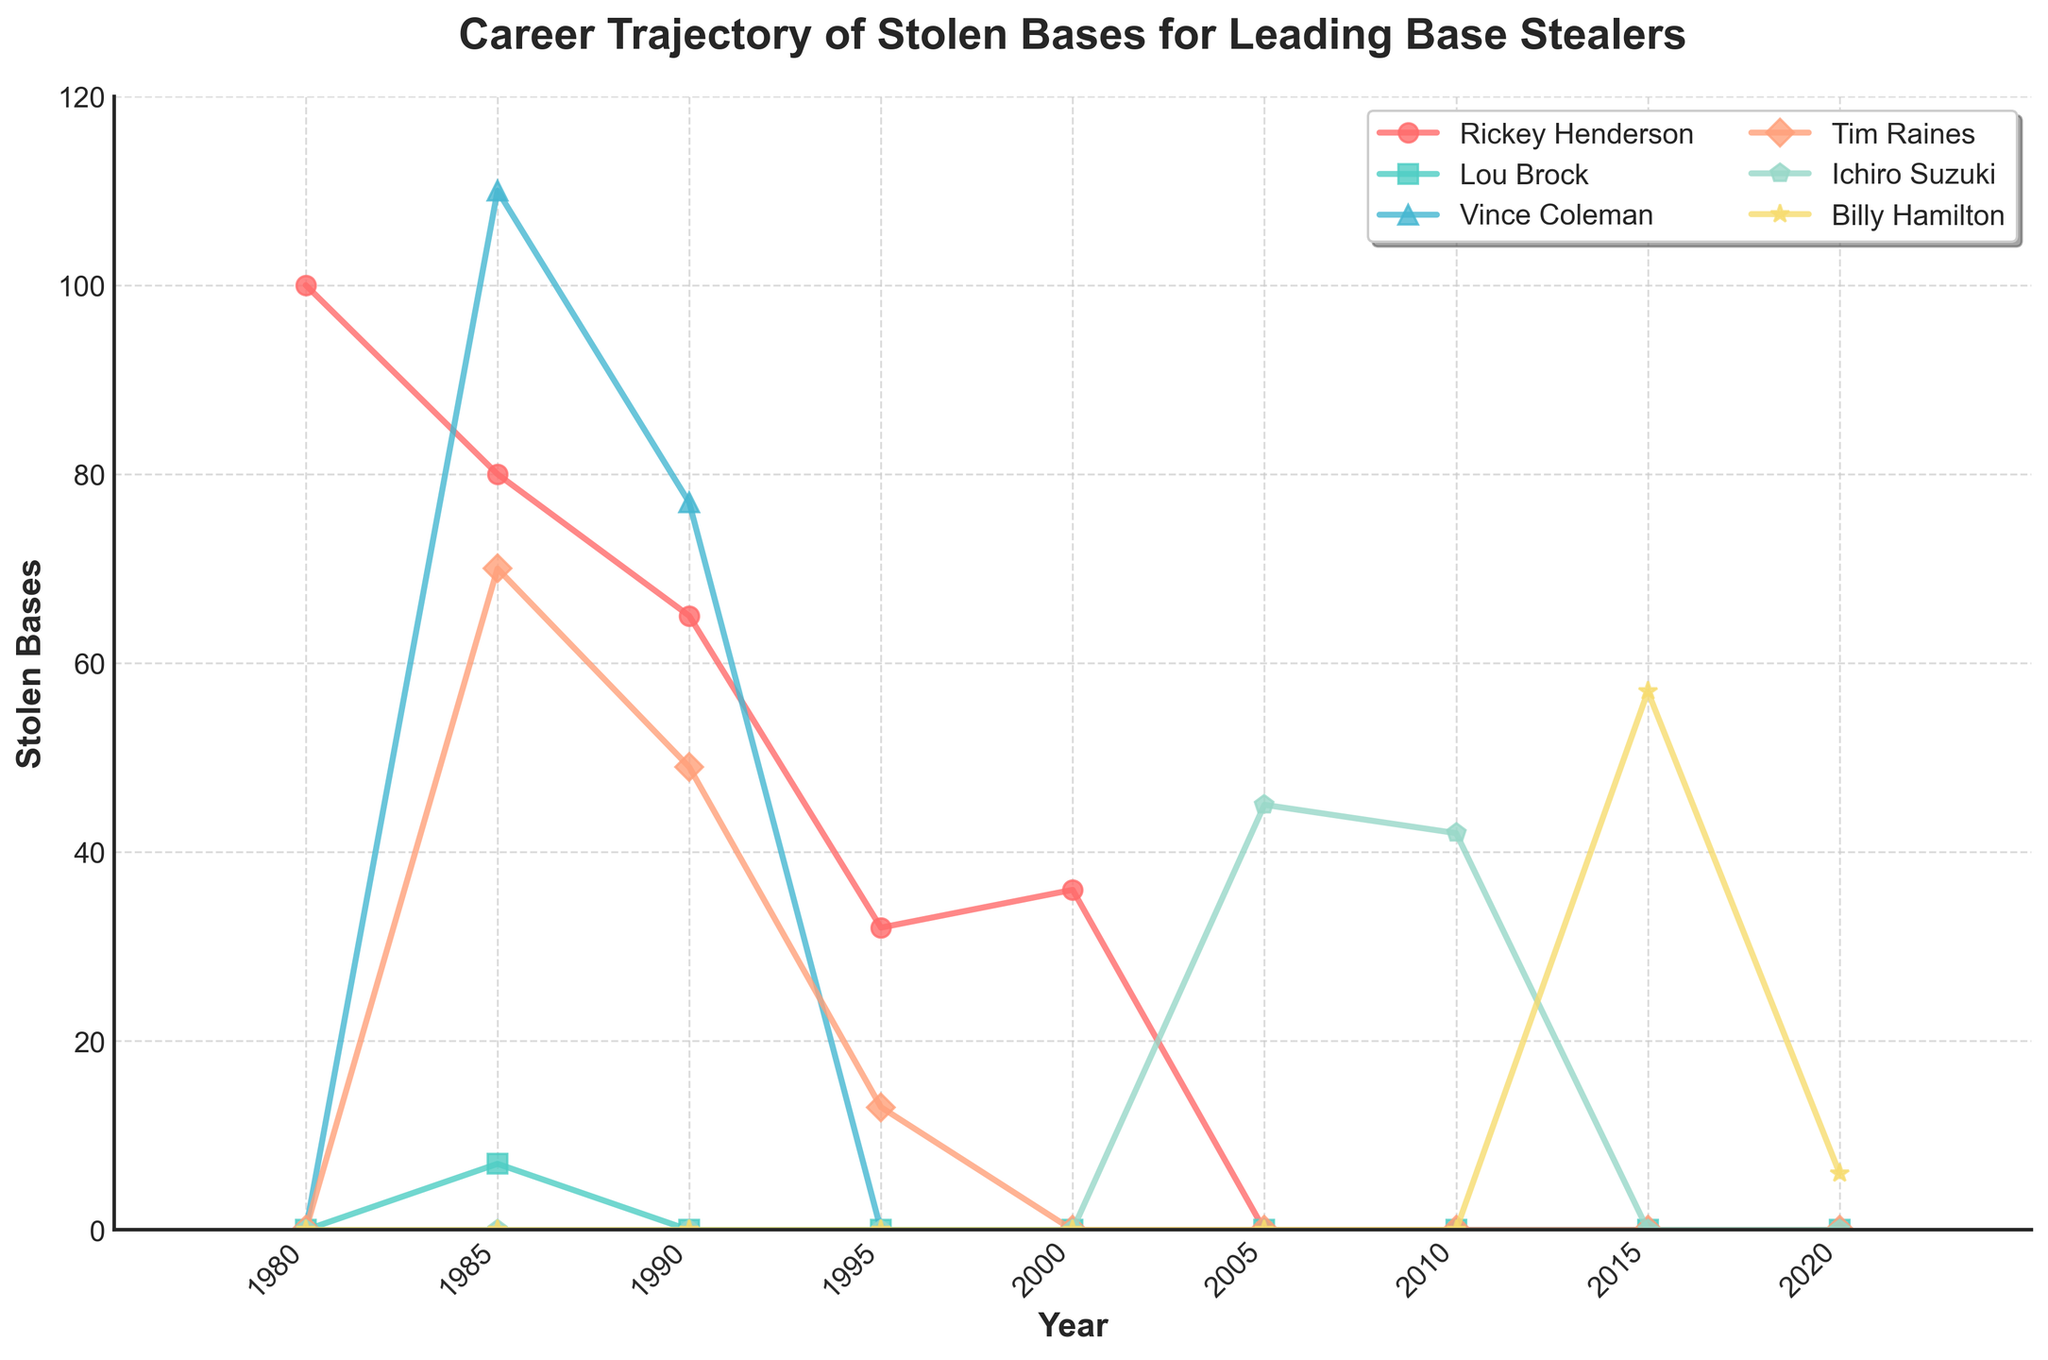What is the highest number of stolen bases recorded by any player on the chart and who achieved it? By examining the plotted lines and their highest points, we can see that Rickey Henderson achieved the highest number with 100 stolen bases in 1980.
Answer: Rickey Henderson with 100 stolen bases in 1980 Between 1985 and 1990, whose stolen bases decreased the most? We observe the slopes from 1985 to 1990 for each player. Rickey Henderson's and Vince Coleman's numbers decreased. Rickey Henderson went from 80 to 65 (a decrease of 15), while Vince Coleman went from 110 to 77 (a decrease of 33), making Vince's decrease the most.
Answer: Vince Coleman How many stolen bases did Ichiro Suzuki achieve in 2005 and 2010 combined? Look at the values for Ichiro Suzuki in those specific years: 45 in 2005 and 42 in 2010. Adding them together, 45 + 42 = 87.
Answer: 87 Whose stolen base count remained zero throughout the decades? By checking each player's line across all years in the chart, Lou Brock's line remains at zero except for 7 bases in 1985, meaning the answer is none since Lou Brock also has one non-zero value.
Answer: None Which player's stolen bases show the most consistent decrease over the decades? Tim Raines' line shows a consistent downward trend without fluctuating, making him the answer.
Answer: Tim Raines Compare the stolen bases for Billy Hamilton in 2015 and 2020. Who had more? Looking at the values in the specified years for Billy Hamilton, 57 in 2015 and 6 in 2020. 57 is greater than 6.
Answer: More in 2015 Which years did Rickey Henderson record zero stolen bases? Review Rickey Henderson's line; it shows zero in 2005, 2010, 2015, and 2020.
Answer: 2005, 2010, 2015, and 2020 Among Rickey Henderson, Vince Coleman, and Tim Raines, who had the maximum stolen bases in 1985? Refer to their values in 1985, Rickey Henderson had 80, Vince Coleman had 110, and Tim Raines had 70. Vince Coleman had the highest with 110.
Answer: Vince Coleman in 1985 In which year did Ichiro Suzuki record the highest number of stolen bases? Ichiro Suzuki's highest value on the plot is 45 in 2005, his largest data point.
Answer: 2005 What is the sum of stolen bases for Tim Raines from 1980 to 1990? Sum Tim Raines' stolen bases from the years 1985 (70) and 1990 (49). Calculate: 70 + 49 = 119.
Answer: 119 